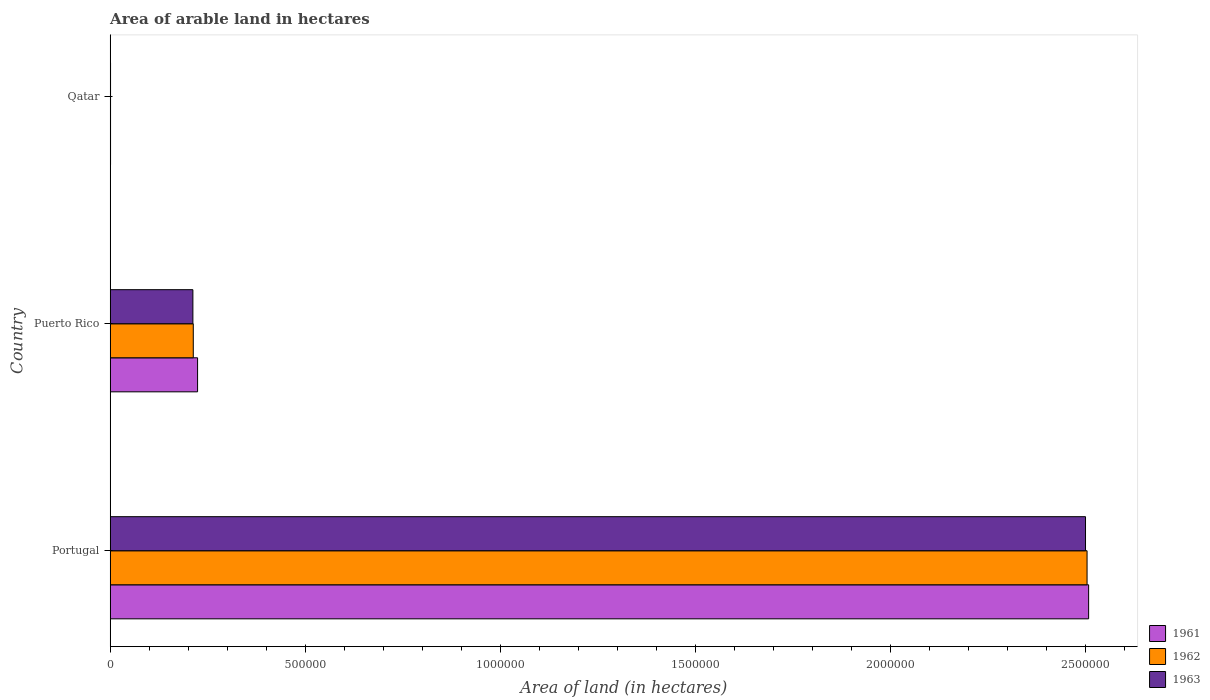How many groups of bars are there?
Offer a terse response. 3. Are the number of bars per tick equal to the number of legend labels?
Make the answer very short. Yes. Are the number of bars on each tick of the Y-axis equal?
Give a very brief answer. Yes. How many bars are there on the 2nd tick from the top?
Ensure brevity in your answer.  3. How many bars are there on the 1st tick from the bottom?
Keep it short and to the point. 3. In how many cases, is the number of bars for a given country not equal to the number of legend labels?
Provide a succinct answer. 0. What is the total arable land in 1962 in Qatar?
Offer a very short reply. 1000. Across all countries, what is the maximum total arable land in 1961?
Provide a succinct answer. 2.51e+06. In which country was the total arable land in 1963 maximum?
Keep it short and to the point. Portugal. In which country was the total arable land in 1962 minimum?
Make the answer very short. Qatar. What is the total total arable land in 1963 in the graph?
Your answer should be compact. 2.71e+06. What is the difference between the total arable land in 1961 in Portugal and that in Puerto Rico?
Ensure brevity in your answer.  2.28e+06. What is the difference between the total arable land in 1961 in Qatar and the total arable land in 1963 in Portugal?
Your answer should be very brief. -2.50e+06. What is the average total arable land in 1962 per country?
Offer a very short reply. 9.06e+05. What is the difference between the total arable land in 1962 and total arable land in 1961 in Puerto Rico?
Give a very brief answer. -1.10e+04. In how many countries, is the total arable land in 1963 greater than 900000 hectares?
Your answer should be very brief. 1. What is the ratio of the total arable land in 1963 in Portugal to that in Puerto Rico?
Offer a terse response. 11.79. Is the total arable land in 1963 in Portugal less than that in Puerto Rico?
Offer a terse response. No. Is the difference between the total arable land in 1962 in Puerto Rico and Qatar greater than the difference between the total arable land in 1961 in Puerto Rico and Qatar?
Make the answer very short. No. What is the difference between the highest and the second highest total arable land in 1961?
Your answer should be compact. 2.28e+06. What is the difference between the highest and the lowest total arable land in 1961?
Make the answer very short. 2.51e+06. In how many countries, is the total arable land in 1961 greater than the average total arable land in 1961 taken over all countries?
Your answer should be very brief. 1. What does the 2nd bar from the top in Puerto Rico represents?
Offer a very short reply. 1962. What does the 1st bar from the bottom in Portugal represents?
Your answer should be very brief. 1961. How many bars are there?
Your response must be concise. 9. Are all the bars in the graph horizontal?
Keep it short and to the point. Yes. How many countries are there in the graph?
Your response must be concise. 3. What is the difference between two consecutive major ticks on the X-axis?
Provide a short and direct response. 5.00e+05. Are the values on the major ticks of X-axis written in scientific E-notation?
Your answer should be compact. No. How are the legend labels stacked?
Provide a succinct answer. Vertical. What is the title of the graph?
Provide a succinct answer. Area of arable land in hectares. What is the label or title of the X-axis?
Ensure brevity in your answer.  Area of land (in hectares). What is the Area of land (in hectares) of 1961 in Portugal?
Provide a short and direct response. 2.51e+06. What is the Area of land (in hectares) in 1962 in Portugal?
Give a very brief answer. 2.50e+06. What is the Area of land (in hectares) in 1963 in Portugal?
Your answer should be compact. 2.50e+06. What is the Area of land (in hectares) of 1961 in Puerto Rico?
Your answer should be compact. 2.24e+05. What is the Area of land (in hectares) in 1962 in Puerto Rico?
Offer a very short reply. 2.13e+05. What is the Area of land (in hectares) in 1963 in Puerto Rico?
Your answer should be compact. 2.12e+05. What is the Area of land (in hectares) of 1962 in Qatar?
Ensure brevity in your answer.  1000. What is the Area of land (in hectares) of 1963 in Qatar?
Make the answer very short. 1000. Across all countries, what is the maximum Area of land (in hectares) of 1961?
Your response must be concise. 2.51e+06. Across all countries, what is the maximum Area of land (in hectares) of 1962?
Provide a short and direct response. 2.50e+06. Across all countries, what is the maximum Area of land (in hectares) of 1963?
Ensure brevity in your answer.  2.50e+06. Across all countries, what is the minimum Area of land (in hectares) of 1962?
Your response must be concise. 1000. Across all countries, what is the minimum Area of land (in hectares) in 1963?
Offer a terse response. 1000. What is the total Area of land (in hectares) of 1961 in the graph?
Make the answer very short. 2.73e+06. What is the total Area of land (in hectares) of 1962 in the graph?
Keep it short and to the point. 2.72e+06. What is the total Area of land (in hectares) in 1963 in the graph?
Ensure brevity in your answer.  2.71e+06. What is the difference between the Area of land (in hectares) in 1961 in Portugal and that in Puerto Rico?
Your answer should be compact. 2.28e+06. What is the difference between the Area of land (in hectares) of 1962 in Portugal and that in Puerto Rico?
Your response must be concise. 2.29e+06. What is the difference between the Area of land (in hectares) in 1963 in Portugal and that in Puerto Rico?
Make the answer very short. 2.29e+06. What is the difference between the Area of land (in hectares) of 1961 in Portugal and that in Qatar?
Give a very brief answer. 2.51e+06. What is the difference between the Area of land (in hectares) of 1962 in Portugal and that in Qatar?
Your answer should be compact. 2.50e+06. What is the difference between the Area of land (in hectares) in 1963 in Portugal and that in Qatar?
Your answer should be compact. 2.50e+06. What is the difference between the Area of land (in hectares) of 1961 in Puerto Rico and that in Qatar?
Give a very brief answer. 2.23e+05. What is the difference between the Area of land (in hectares) of 1962 in Puerto Rico and that in Qatar?
Make the answer very short. 2.12e+05. What is the difference between the Area of land (in hectares) of 1963 in Puerto Rico and that in Qatar?
Keep it short and to the point. 2.11e+05. What is the difference between the Area of land (in hectares) in 1961 in Portugal and the Area of land (in hectares) in 1962 in Puerto Rico?
Provide a succinct answer. 2.29e+06. What is the difference between the Area of land (in hectares) in 1961 in Portugal and the Area of land (in hectares) in 1963 in Puerto Rico?
Ensure brevity in your answer.  2.30e+06. What is the difference between the Area of land (in hectares) of 1962 in Portugal and the Area of land (in hectares) of 1963 in Puerto Rico?
Give a very brief answer. 2.29e+06. What is the difference between the Area of land (in hectares) of 1961 in Portugal and the Area of land (in hectares) of 1962 in Qatar?
Make the answer very short. 2.51e+06. What is the difference between the Area of land (in hectares) of 1961 in Portugal and the Area of land (in hectares) of 1963 in Qatar?
Offer a terse response. 2.51e+06. What is the difference between the Area of land (in hectares) in 1962 in Portugal and the Area of land (in hectares) in 1963 in Qatar?
Give a very brief answer. 2.50e+06. What is the difference between the Area of land (in hectares) of 1961 in Puerto Rico and the Area of land (in hectares) of 1962 in Qatar?
Ensure brevity in your answer.  2.23e+05. What is the difference between the Area of land (in hectares) in 1961 in Puerto Rico and the Area of land (in hectares) in 1963 in Qatar?
Your response must be concise. 2.23e+05. What is the difference between the Area of land (in hectares) in 1962 in Puerto Rico and the Area of land (in hectares) in 1963 in Qatar?
Offer a terse response. 2.12e+05. What is the average Area of land (in hectares) in 1961 per country?
Give a very brief answer. 9.11e+05. What is the average Area of land (in hectares) of 1962 per country?
Give a very brief answer. 9.06e+05. What is the average Area of land (in hectares) in 1963 per country?
Give a very brief answer. 9.04e+05. What is the difference between the Area of land (in hectares) in 1961 and Area of land (in hectares) in 1962 in Portugal?
Your response must be concise. 4000. What is the difference between the Area of land (in hectares) in 1961 and Area of land (in hectares) in 1963 in Portugal?
Offer a terse response. 8000. What is the difference between the Area of land (in hectares) of 1962 and Area of land (in hectares) of 1963 in Portugal?
Give a very brief answer. 4000. What is the difference between the Area of land (in hectares) in 1961 and Area of land (in hectares) in 1962 in Puerto Rico?
Offer a terse response. 1.10e+04. What is the difference between the Area of land (in hectares) in 1961 and Area of land (in hectares) in 1963 in Puerto Rico?
Your response must be concise. 1.20e+04. What is the difference between the Area of land (in hectares) in 1961 and Area of land (in hectares) in 1962 in Qatar?
Your answer should be compact. 0. What is the difference between the Area of land (in hectares) in 1962 and Area of land (in hectares) in 1963 in Qatar?
Offer a terse response. 0. What is the ratio of the Area of land (in hectares) of 1961 in Portugal to that in Puerto Rico?
Your response must be concise. 11.19. What is the ratio of the Area of land (in hectares) of 1962 in Portugal to that in Puerto Rico?
Provide a succinct answer. 11.75. What is the ratio of the Area of land (in hectares) in 1963 in Portugal to that in Puerto Rico?
Your answer should be very brief. 11.79. What is the ratio of the Area of land (in hectares) of 1961 in Portugal to that in Qatar?
Your answer should be compact. 2507. What is the ratio of the Area of land (in hectares) of 1962 in Portugal to that in Qatar?
Offer a terse response. 2503. What is the ratio of the Area of land (in hectares) in 1963 in Portugal to that in Qatar?
Offer a terse response. 2499. What is the ratio of the Area of land (in hectares) in 1961 in Puerto Rico to that in Qatar?
Provide a succinct answer. 224. What is the ratio of the Area of land (in hectares) of 1962 in Puerto Rico to that in Qatar?
Keep it short and to the point. 213. What is the ratio of the Area of land (in hectares) of 1963 in Puerto Rico to that in Qatar?
Give a very brief answer. 212. What is the difference between the highest and the second highest Area of land (in hectares) of 1961?
Keep it short and to the point. 2.28e+06. What is the difference between the highest and the second highest Area of land (in hectares) of 1962?
Offer a very short reply. 2.29e+06. What is the difference between the highest and the second highest Area of land (in hectares) in 1963?
Offer a terse response. 2.29e+06. What is the difference between the highest and the lowest Area of land (in hectares) in 1961?
Make the answer very short. 2.51e+06. What is the difference between the highest and the lowest Area of land (in hectares) of 1962?
Ensure brevity in your answer.  2.50e+06. What is the difference between the highest and the lowest Area of land (in hectares) of 1963?
Your answer should be very brief. 2.50e+06. 